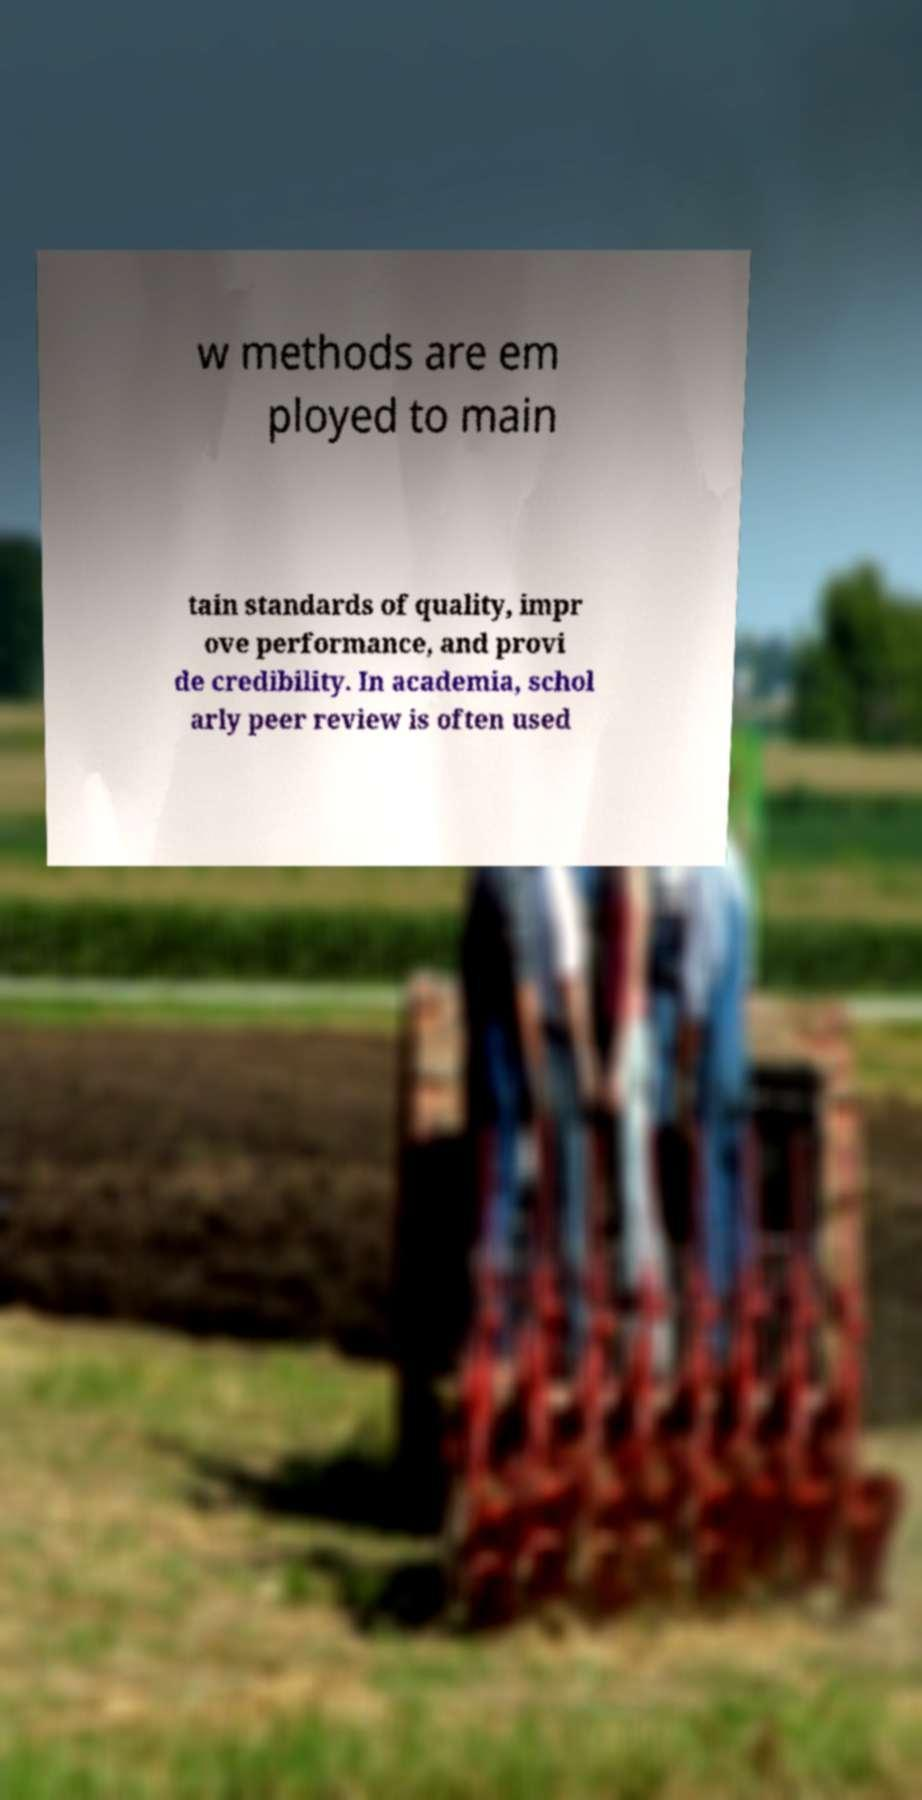Please identify and transcribe the text found in this image. w methods are em ployed to main tain standards of quality, impr ove performance, and provi de credibility. In academia, schol arly peer review is often used 